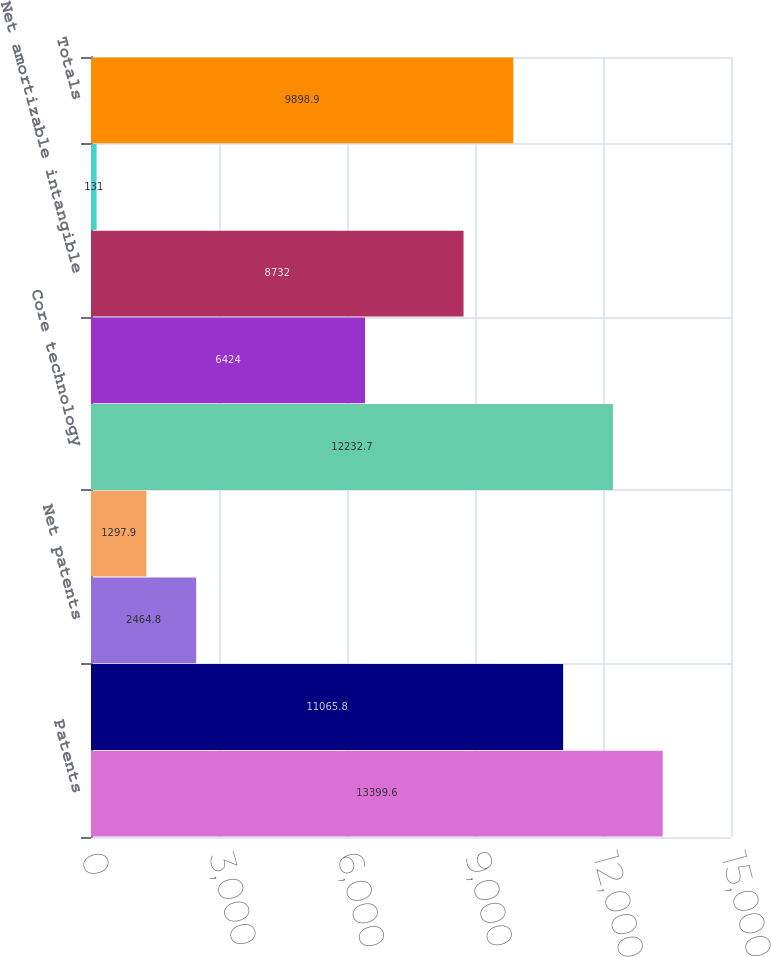Convert chart. <chart><loc_0><loc_0><loc_500><loc_500><bar_chart><fcel>Patents<fcel>Less Accumulated amortization<fcel>Net patents<fcel>Licenses<fcel>Core technology<fcel>Net core technology<fcel>Net amortizable intangible<fcel>Trade names and trademarks<fcel>Totals<nl><fcel>13399.6<fcel>11065.8<fcel>2464.8<fcel>1297.9<fcel>12232.7<fcel>6424<fcel>8732<fcel>131<fcel>9898.9<nl></chart> 